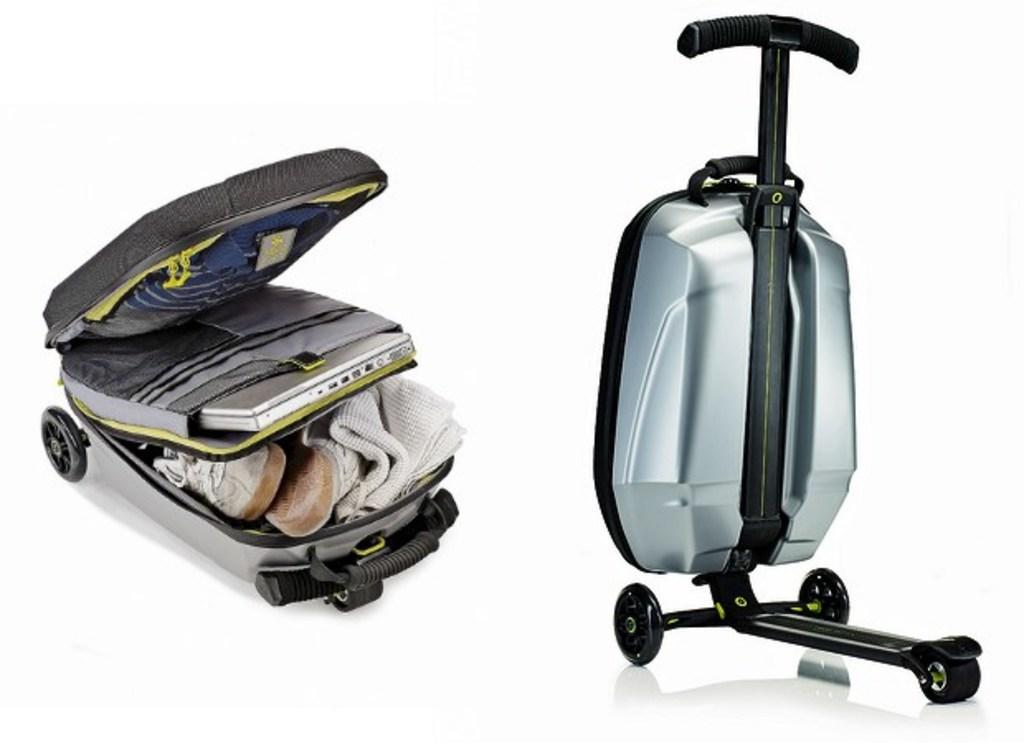Please provide a concise description of this image. It's a luggage box in which we have towel,shoes,laptop,T-shirt and it has wheels right side we have an image. 